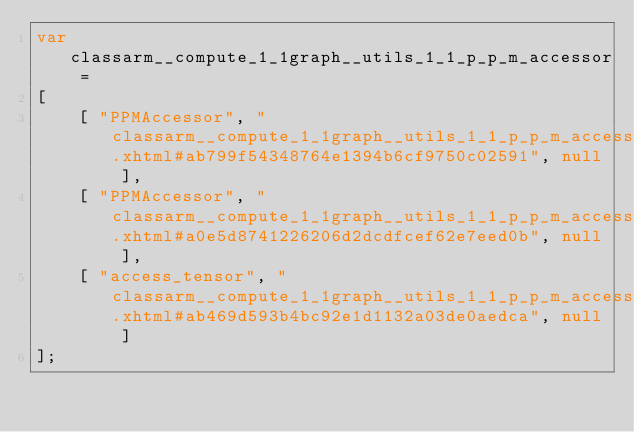<code> <loc_0><loc_0><loc_500><loc_500><_JavaScript_>var classarm__compute_1_1graph__utils_1_1_p_p_m_accessor =
[
    [ "PPMAccessor", "classarm__compute_1_1graph__utils_1_1_p_p_m_accessor.xhtml#ab799f54348764e1394b6cf9750c02591", null ],
    [ "PPMAccessor", "classarm__compute_1_1graph__utils_1_1_p_p_m_accessor.xhtml#a0e5d8741226206d2dcdfcef62e7eed0b", null ],
    [ "access_tensor", "classarm__compute_1_1graph__utils_1_1_p_p_m_accessor.xhtml#ab469d593b4bc92e1d1132a03de0aedca", null ]
];</code> 